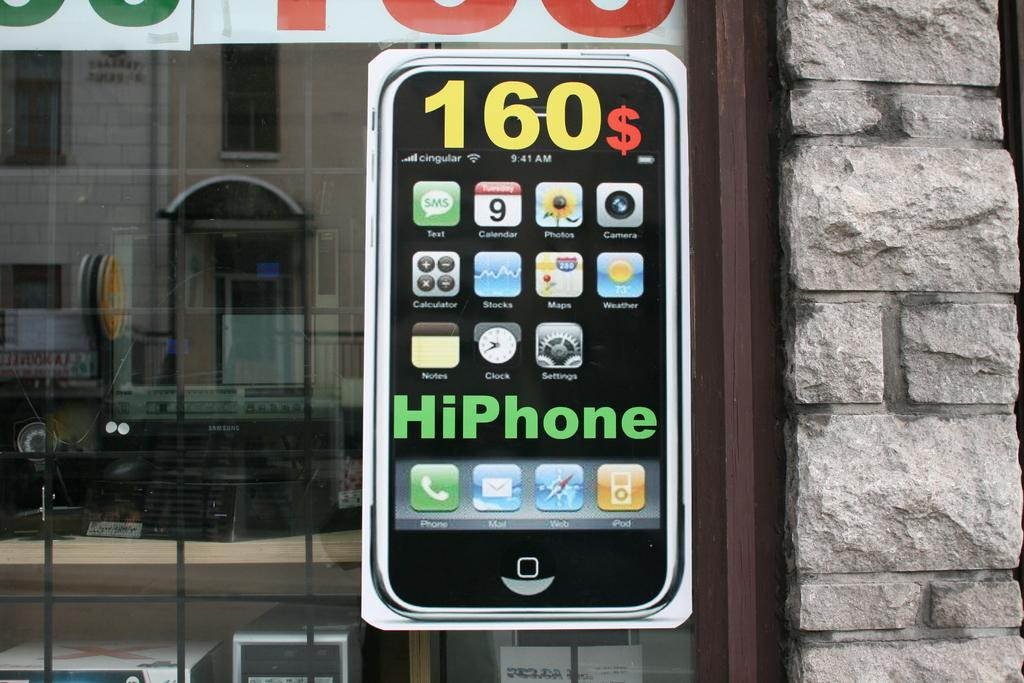Provide a one-sentence caption for the provided image. An advertisement on a window shows one can buy a phone for 160$. 